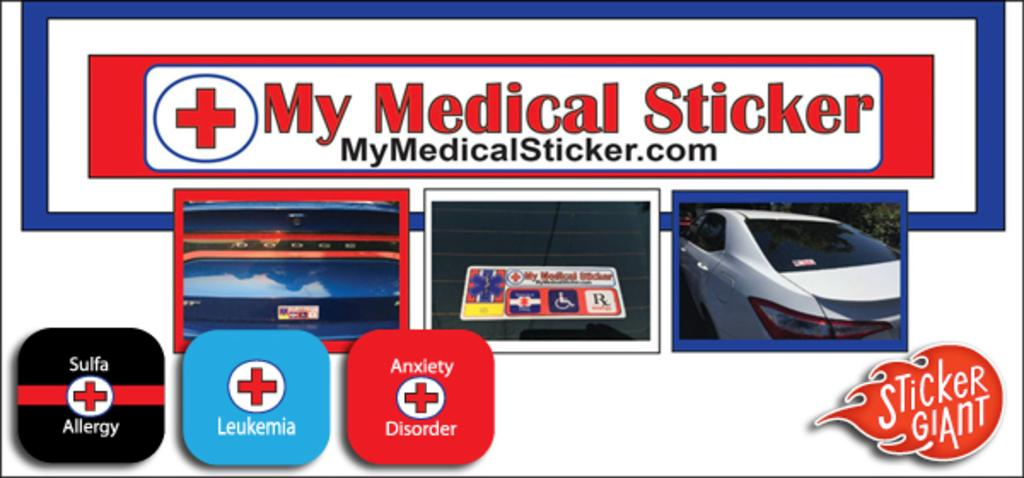What is the main subject of the photos in the image? The main subject of the photos in the image is a car. Are there any other objects or elements visible in the photos? Yes, there are other things visible in the photos. Can you describe any text or writing present in the image? There is writing in the image at a few places. How many frogs can be seen in the image? There are no frogs present in the image. What type of punishment is being given to the car in the image? There is no punishment being given to the car in the image; it is just a subject of the photos. 